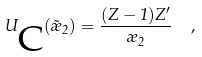<formula> <loc_0><loc_0><loc_500><loc_500>U _ { \mbox C } ( \vec { \rho } _ { 2 } ) = \frac { ( Z - 1 ) Z ^ { \prime } } { \rho _ { 2 } } \ \ ,</formula> 